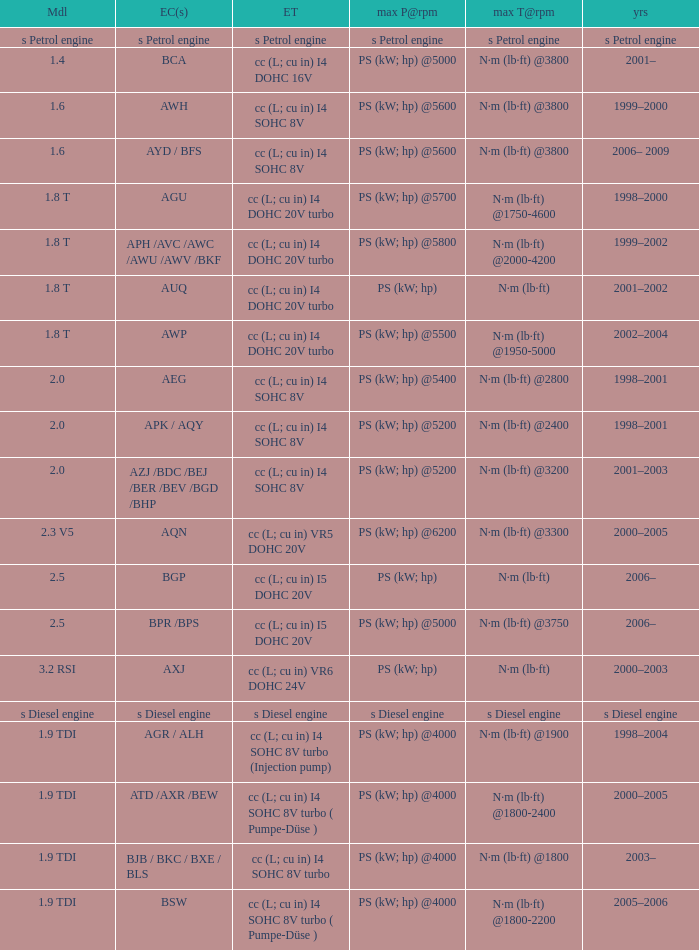What was the max torque@rpm of the engine which had the model 2.5  and a max power@rpm of ps (kw; hp) @5000? N·m (lb·ft) @3750. 